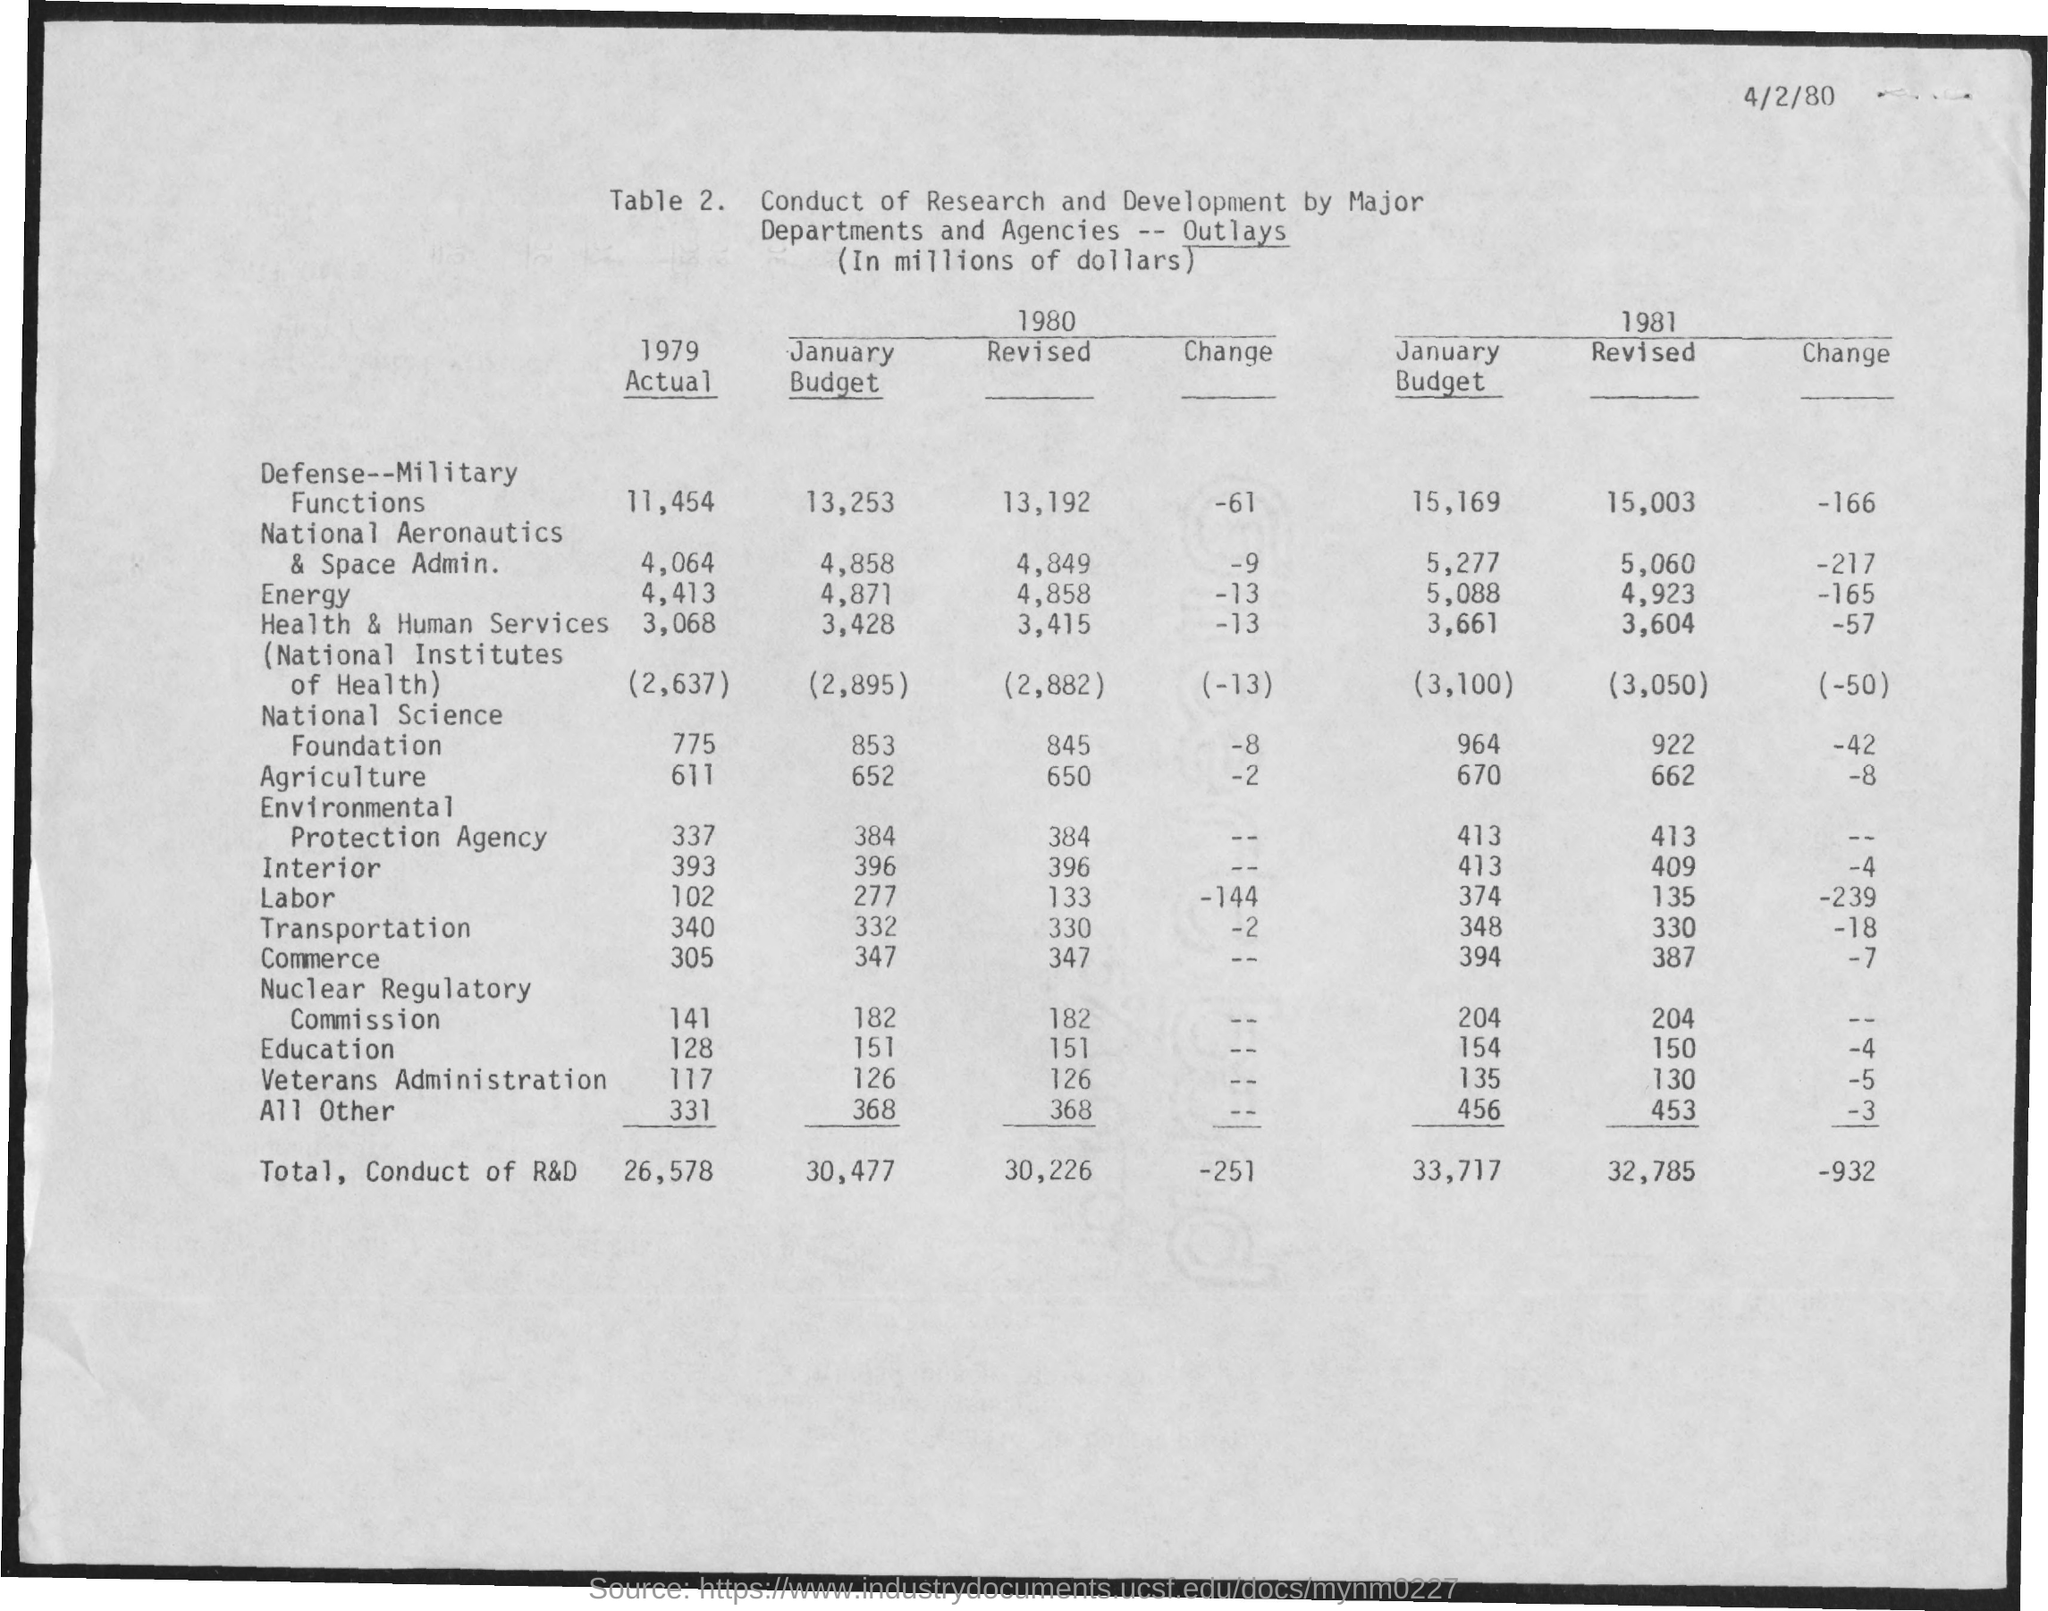What is the date mentioned in the document?
Ensure brevity in your answer.  4/2/80. 